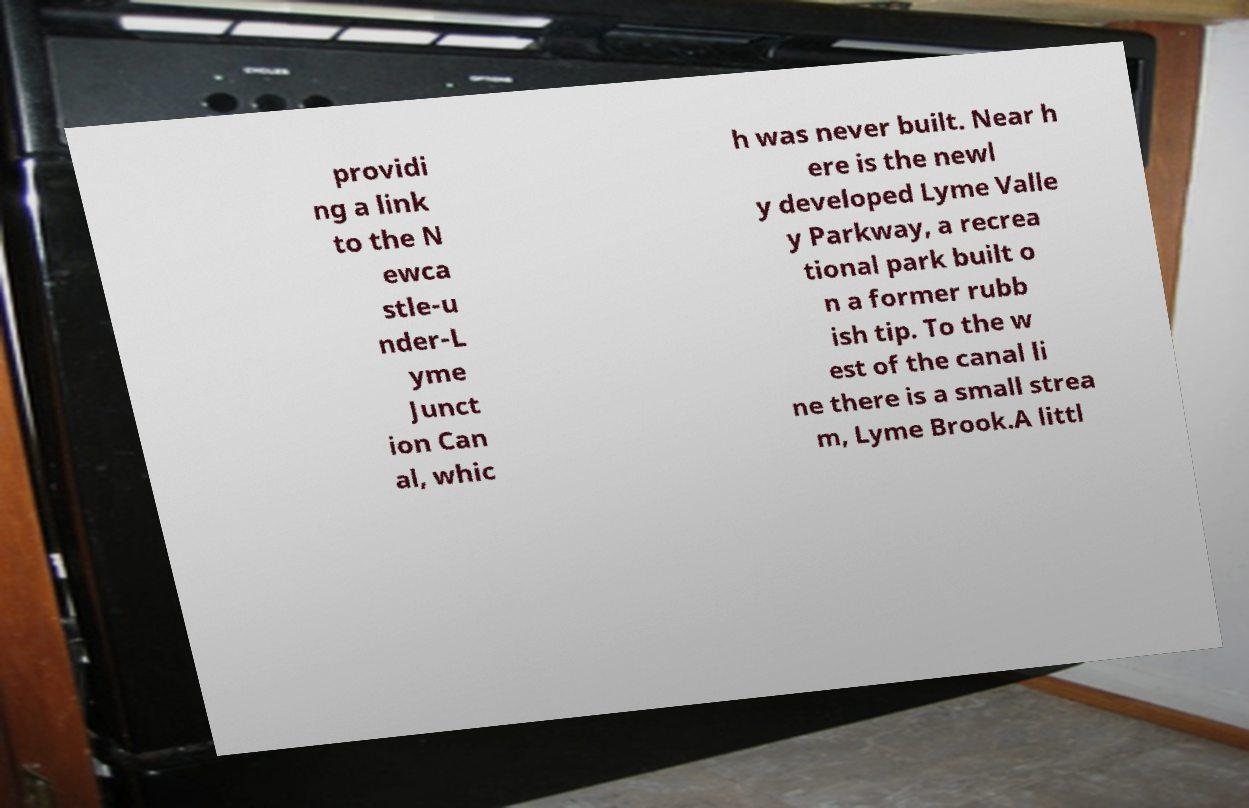For documentation purposes, I need the text within this image transcribed. Could you provide that? providi ng a link to the N ewca stle-u nder-L yme Junct ion Can al, whic h was never built. Near h ere is the newl y developed Lyme Valle y Parkway, a recrea tional park built o n a former rubb ish tip. To the w est of the canal li ne there is a small strea m, Lyme Brook.A littl 